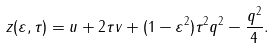<formula> <loc_0><loc_0><loc_500><loc_500>z ( \varepsilon , \tau ) = u + 2 \tau v + ( 1 - \varepsilon ^ { 2 } ) \tau ^ { 2 } q ^ { 2 } - \frac { q ^ { 2 } } { 4 } .</formula> 